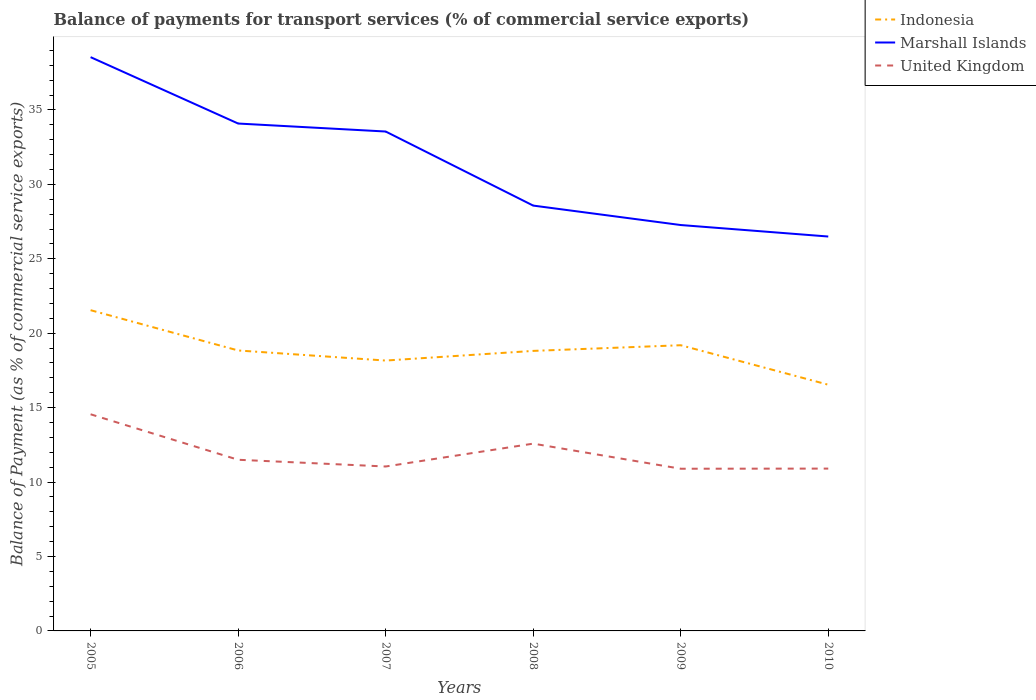How many different coloured lines are there?
Give a very brief answer. 3. Does the line corresponding to United Kingdom intersect with the line corresponding to Marshall Islands?
Give a very brief answer. No. Across all years, what is the maximum balance of payments for transport services in Indonesia?
Ensure brevity in your answer.  16.54. In which year was the balance of payments for transport services in Indonesia maximum?
Keep it short and to the point. 2010. What is the total balance of payments for transport services in United Kingdom in the graph?
Make the answer very short. 3.06. What is the difference between the highest and the second highest balance of payments for transport services in Indonesia?
Keep it short and to the point. 5.01. What is the difference between the highest and the lowest balance of payments for transport services in Marshall Islands?
Offer a terse response. 3. How many lines are there?
Offer a terse response. 3. How many years are there in the graph?
Your response must be concise. 6. Does the graph contain any zero values?
Ensure brevity in your answer.  No. Does the graph contain grids?
Provide a short and direct response. No. Where does the legend appear in the graph?
Make the answer very short. Top right. What is the title of the graph?
Give a very brief answer. Balance of payments for transport services (% of commercial service exports). Does "Singapore" appear as one of the legend labels in the graph?
Make the answer very short. No. What is the label or title of the Y-axis?
Offer a terse response. Balance of Payment (as % of commercial service exports). What is the Balance of Payment (as % of commercial service exports) of Indonesia in 2005?
Give a very brief answer. 21.55. What is the Balance of Payment (as % of commercial service exports) of Marshall Islands in 2005?
Your answer should be compact. 38.55. What is the Balance of Payment (as % of commercial service exports) in United Kingdom in 2005?
Your answer should be compact. 14.55. What is the Balance of Payment (as % of commercial service exports) of Indonesia in 2006?
Give a very brief answer. 18.84. What is the Balance of Payment (as % of commercial service exports) in Marshall Islands in 2006?
Give a very brief answer. 34.09. What is the Balance of Payment (as % of commercial service exports) of United Kingdom in 2006?
Your response must be concise. 11.5. What is the Balance of Payment (as % of commercial service exports) of Indonesia in 2007?
Keep it short and to the point. 18.16. What is the Balance of Payment (as % of commercial service exports) in Marshall Islands in 2007?
Provide a short and direct response. 33.55. What is the Balance of Payment (as % of commercial service exports) of United Kingdom in 2007?
Your answer should be compact. 11.05. What is the Balance of Payment (as % of commercial service exports) of Indonesia in 2008?
Provide a short and direct response. 18.81. What is the Balance of Payment (as % of commercial service exports) of Marshall Islands in 2008?
Your response must be concise. 28.57. What is the Balance of Payment (as % of commercial service exports) in United Kingdom in 2008?
Give a very brief answer. 12.58. What is the Balance of Payment (as % of commercial service exports) in Indonesia in 2009?
Offer a terse response. 19.19. What is the Balance of Payment (as % of commercial service exports) of Marshall Islands in 2009?
Provide a short and direct response. 27.27. What is the Balance of Payment (as % of commercial service exports) in United Kingdom in 2009?
Keep it short and to the point. 10.9. What is the Balance of Payment (as % of commercial service exports) of Indonesia in 2010?
Your answer should be very brief. 16.54. What is the Balance of Payment (as % of commercial service exports) in Marshall Islands in 2010?
Make the answer very short. 26.5. What is the Balance of Payment (as % of commercial service exports) of United Kingdom in 2010?
Your answer should be very brief. 10.91. Across all years, what is the maximum Balance of Payment (as % of commercial service exports) of Indonesia?
Provide a succinct answer. 21.55. Across all years, what is the maximum Balance of Payment (as % of commercial service exports) of Marshall Islands?
Your answer should be compact. 38.55. Across all years, what is the maximum Balance of Payment (as % of commercial service exports) of United Kingdom?
Offer a terse response. 14.55. Across all years, what is the minimum Balance of Payment (as % of commercial service exports) in Indonesia?
Offer a terse response. 16.54. Across all years, what is the minimum Balance of Payment (as % of commercial service exports) of Marshall Islands?
Provide a succinct answer. 26.5. Across all years, what is the minimum Balance of Payment (as % of commercial service exports) in United Kingdom?
Keep it short and to the point. 10.9. What is the total Balance of Payment (as % of commercial service exports) of Indonesia in the graph?
Make the answer very short. 113.09. What is the total Balance of Payment (as % of commercial service exports) in Marshall Islands in the graph?
Offer a very short reply. 188.52. What is the total Balance of Payment (as % of commercial service exports) in United Kingdom in the graph?
Offer a very short reply. 71.48. What is the difference between the Balance of Payment (as % of commercial service exports) in Indonesia in 2005 and that in 2006?
Offer a terse response. 2.71. What is the difference between the Balance of Payment (as % of commercial service exports) of Marshall Islands in 2005 and that in 2006?
Your answer should be very brief. 4.46. What is the difference between the Balance of Payment (as % of commercial service exports) in United Kingdom in 2005 and that in 2006?
Your response must be concise. 3.06. What is the difference between the Balance of Payment (as % of commercial service exports) of Indonesia in 2005 and that in 2007?
Offer a terse response. 3.38. What is the difference between the Balance of Payment (as % of commercial service exports) in Marshall Islands in 2005 and that in 2007?
Give a very brief answer. 5. What is the difference between the Balance of Payment (as % of commercial service exports) in United Kingdom in 2005 and that in 2007?
Offer a terse response. 3.51. What is the difference between the Balance of Payment (as % of commercial service exports) of Indonesia in 2005 and that in 2008?
Ensure brevity in your answer.  2.73. What is the difference between the Balance of Payment (as % of commercial service exports) in Marshall Islands in 2005 and that in 2008?
Ensure brevity in your answer.  9.97. What is the difference between the Balance of Payment (as % of commercial service exports) in United Kingdom in 2005 and that in 2008?
Your response must be concise. 1.97. What is the difference between the Balance of Payment (as % of commercial service exports) in Indonesia in 2005 and that in 2009?
Make the answer very short. 2.35. What is the difference between the Balance of Payment (as % of commercial service exports) of Marshall Islands in 2005 and that in 2009?
Ensure brevity in your answer.  11.28. What is the difference between the Balance of Payment (as % of commercial service exports) in United Kingdom in 2005 and that in 2009?
Provide a succinct answer. 3.66. What is the difference between the Balance of Payment (as % of commercial service exports) in Indonesia in 2005 and that in 2010?
Provide a short and direct response. 5.01. What is the difference between the Balance of Payment (as % of commercial service exports) of Marshall Islands in 2005 and that in 2010?
Make the answer very short. 12.05. What is the difference between the Balance of Payment (as % of commercial service exports) in United Kingdom in 2005 and that in 2010?
Ensure brevity in your answer.  3.65. What is the difference between the Balance of Payment (as % of commercial service exports) of Indonesia in 2006 and that in 2007?
Your response must be concise. 0.68. What is the difference between the Balance of Payment (as % of commercial service exports) in Marshall Islands in 2006 and that in 2007?
Ensure brevity in your answer.  0.54. What is the difference between the Balance of Payment (as % of commercial service exports) of United Kingdom in 2006 and that in 2007?
Give a very brief answer. 0.45. What is the difference between the Balance of Payment (as % of commercial service exports) of Indonesia in 2006 and that in 2008?
Give a very brief answer. 0.03. What is the difference between the Balance of Payment (as % of commercial service exports) of Marshall Islands in 2006 and that in 2008?
Your answer should be very brief. 5.51. What is the difference between the Balance of Payment (as % of commercial service exports) in United Kingdom in 2006 and that in 2008?
Provide a short and direct response. -1.08. What is the difference between the Balance of Payment (as % of commercial service exports) in Indonesia in 2006 and that in 2009?
Your response must be concise. -0.35. What is the difference between the Balance of Payment (as % of commercial service exports) in Marshall Islands in 2006 and that in 2009?
Keep it short and to the point. 6.82. What is the difference between the Balance of Payment (as % of commercial service exports) in United Kingdom in 2006 and that in 2009?
Make the answer very short. 0.6. What is the difference between the Balance of Payment (as % of commercial service exports) in Indonesia in 2006 and that in 2010?
Your answer should be compact. 2.3. What is the difference between the Balance of Payment (as % of commercial service exports) in Marshall Islands in 2006 and that in 2010?
Offer a very short reply. 7.59. What is the difference between the Balance of Payment (as % of commercial service exports) of United Kingdom in 2006 and that in 2010?
Your answer should be very brief. 0.59. What is the difference between the Balance of Payment (as % of commercial service exports) of Indonesia in 2007 and that in 2008?
Ensure brevity in your answer.  -0.65. What is the difference between the Balance of Payment (as % of commercial service exports) in Marshall Islands in 2007 and that in 2008?
Give a very brief answer. 4.98. What is the difference between the Balance of Payment (as % of commercial service exports) in United Kingdom in 2007 and that in 2008?
Give a very brief answer. -1.54. What is the difference between the Balance of Payment (as % of commercial service exports) in Indonesia in 2007 and that in 2009?
Offer a very short reply. -1.03. What is the difference between the Balance of Payment (as % of commercial service exports) of Marshall Islands in 2007 and that in 2009?
Give a very brief answer. 6.28. What is the difference between the Balance of Payment (as % of commercial service exports) of United Kingdom in 2007 and that in 2009?
Offer a very short reply. 0.15. What is the difference between the Balance of Payment (as % of commercial service exports) of Indonesia in 2007 and that in 2010?
Make the answer very short. 1.62. What is the difference between the Balance of Payment (as % of commercial service exports) in Marshall Islands in 2007 and that in 2010?
Offer a terse response. 7.05. What is the difference between the Balance of Payment (as % of commercial service exports) in United Kingdom in 2007 and that in 2010?
Your answer should be very brief. 0.14. What is the difference between the Balance of Payment (as % of commercial service exports) in Indonesia in 2008 and that in 2009?
Ensure brevity in your answer.  -0.38. What is the difference between the Balance of Payment (as % of commercial service exports) in Marshall Islands in 2008 and that in 2009?
Your answer should be very brief. 1.31. What is the difference between the Balance of Payment (as % of commercial service exports) of United Kingdom in 2008 and that in 2009?
Keep it short and to the point. 1.69. What is the difference between the Balance of Payment (as % of commercial service exports) of Indonesia in 2008 and that in 2010?
Your answer should be very brief. 2.27. What is the difference between the Balance of Payment (as % of commercial service exports) in Marshall Islands in 2008 and that in 2010?
Offer a terse response. 2.08. What is the difference between the Balance of Payment (as % of commercial service exports) of United Kingdom in 2008 and that in 2010?
Your answer should be very brief. 1.68. What is the difference between the Balance of Payment (as % of commercial service exports) of Indonesia in 2009 and that in 2010?
Keep it short and to the point. 2.65. What is the difference between the Balance of Payment (as % of commercial service exports) in Marshall Islands in 2009 and that in 2010?
Make the answer very short. 0.77. What is the difference between the Balance of Payment (as % of commercial service exports) in United Kingdom in 2009 and that in 2010?
Ensure brevity in your answer.  -0.01. What is the difference between the Balance of Payment (as % of commercial service exports) in Indonesia in 2005 and the Balance of Payment (as % of commercial service exports) in Marshall Islands in 2006?
Give a very brief answer. -12.54. What is the difference between the Balance of Payment (as % of commercial service exports) in Indonesia in 2005 and the Balance of Payment (as % of commercial service exports) in United Kingdom in 2006?
Provide a succinct answer. 10.05. What is the difference between the Balance of Payment (as % of commercial service exports) in Marshall Islands in 2005 and the Balance of Payment (as % of commercial service exports) in United Kingdom in 2006?
Ensure brevity in your answer.  27.05. What is the difference between the Balance of Payment (as % of commercial service exports) in Indonesia in 2005 and the Balance of Payment (as % of commercial service exports) in Marshall Islands in 2007?
Your response must be concise. -12. What is the difference between the Balance of Payment (as % of commercial service exports) of Indonesia in 2005 and the Balance of Payment (as % of commercial service exports) of United Kingdom in 2007?
Ensure brevity in your answer.  10.5. What is the difference between the Balance of Payment (as % of commercial service exports) in Marshall Islands in 2005 and the Balance of Payment (as % of commercial service exports) in United Kingdom in 2007?
Offer a terse response. 27.5. What is the difference between the Balance of Payment (as % of commercial service exports) in Indonesia in 2005 and the Balance of Payment (as % of commercial service exports) in Marshall Islands in 2008?
Your answer should be very brief. -7.03. What is the difference between the Balance of Payment (as % of commercial service exports) of Indonesia in 2005 and the Balance of Payment (as % of commercial service exports) of United Kingdom in 2008?
Make the answer very short. 8.96. What is the difference between the Balance of Payment (as % of commercial service exports) of Marshall Islands in 2005 and the Balance of Payment (as % of commercial service exports) of United Kingdom in 2008?
Ensure brevity in your answer.  25.96. What is the difference between the Balance of Payment (as % of commercial service exports) in Indonesia in 2005 and the Balance of Payment (as % of commercial service exports) in Marshall Islands in 2009?
Your answer should be very brief. -5.72. What is the difference between the Balance of Payment (as % of commercial service exports) of Indonesia in 2005 and the Balance of Payment (as % of commercial service exports) of United Kingdom in 2009?
Give a very brief answer. 10.65. What is the difference between the Balance of Payment (as % of commercial service exports) of Marshall Islands in 2005 and the Balance of Payment (as % of commercial service exports) of United Kingdom in 2009?
Your answer should be very brief. 27.65. What is the difference between the Balance of Payment (as % of commercial service exports) in Indonesia in 2005 and the Balance of Payment (as % of commercial service exports) in Marshall Islands in 2010?
Offer a very short reply. -4.95. What is the difference between the Balance of Payment (as % of commercial service exports) in Indonesia in 2005 and the Balance of Payment (as % of commercial service exports) in United Kingdom in 2010?
Make the answer very short. 10.64. What is the difference between the Balance of Payment (as % of commercial service exports) in Marshall Islands in 2005 and the Balance of Payment (as % of commercial service exports) in United Kingdom in 2010?
Make the answer very short. 27.64. What is the difference between the Balance of Payment (as % of commercial service exports) of Indonesia in 2006 and the Balance of Payment (as % of commercial service exports) of Marshall Islands in 2007?
Provide a short and direct response. -14.71. What is the difference between the Balance of Payment (as % of commercial service exports) in Indonesia in 2006 and the Balance of Payment (as % of commercial service exports) in United Kingdom in 2007?
Your answer should be compact. 7.8. What is the difference between the Balance of Payment (as % of commercial service exports) in Marshall Islands in 2006 and the Balance of Payment (as % of commercial service exports) in United Kingdom in 2007?
Ensure brevity in your answer.  23.04. What is the difference between the Balance of Payment (as % of commercial service exports) of Indonesia in 2006 and the Balance of Payment (as % of commercial service exports) of Marshall Islands in 2008?
Keep it short and to the point. -9.73. What is the difference between the Balance of Payment (as % of commercial service exports) of Indonesia in 2006 and the Balance of Payment (as % of commercial service exports) of United Kingdom in 2008?
Offer a terse response. 6.26. What is the difference between the Balance of Payment (as % of commercial service exports) in Marshall Islands in 2006 and the Balance of Payment (as % of commercial service exports) in United Kingdom in 2008?
Your response must be concise. 21.5. What is the difference between the Balance of Payment (as % of commercial service exports) of Indonesia in 2006 and the Balance of Payment (as % of commercial service exports) of Marshall Islands in 2009?
Keep it short and to the point. -8.43. What is the difference between the Balance of Payment (as % of commercial service exports) in Indonesia in 2006 and the Balance of Payment (as % of commercial service exports) in United Kingdom in 2009?
Offer a terse response. 7.95. What is the difference between the Balance of Payment (as % of commercial service exports) in Marshall Islands in 2006 and the Balance of Payment (as % of commercial service exports) in United Kingdom in 2009?
Your response must be concise. 23.19. What is the difference between the Balance of Payment (as % of commercial service exports) in Indonesia in 2006 and the Balance of Payment (as % of commercial service exports) in Marshall Islands in 2010?
Offer a terse response. -7.65. What is the difference between the Balance of Payment (as % of commercial service exports) in Indonesia in 2006 and the Balance of Payment (as % of commercial service exports) in United Kingdom in 2010?
Ensure brevity in your answer.  7.94. What is the difference between the Balance of Payment (as % of commercial service exports) of Marshall Islands in 2006 and the Balance of Payment (as % of commercial service exports) of United Kingdom in 2010?
Give a very brief answer. 23.18. What is the difference between the Balance of Payment (as % of commercial service exports) in Indonesia in 2007 and the Balance of Payment (as % of commercial service exports) in Marshall Islands in 2008?
Offer a very short reply. -10.41. What is the difference between the Balance of Payment (as % of commercial service exports) of Indonesia in 2007 and the Balance of Payment (as % of commercial service exports) of United Kingdom in 2008?
Provide a short and direct response. 5.58. What is the difference between the Balance of Payment (as % of commercial service exports) of Marshall Islands in 2007 and the Balance of Payment (as % of commercial service exports) of United Kingdom in 2008?
Give a very brief answer. 20.97. What is the difference between the Balance of Payment (as % of commercial service exports) in Indonesia in 2007 and the Balance of Payment (as % of commercial service exports) in Marshall Islands in 2009?
Your response must be concise. -9.1. What is the difference between the Balance of Payment (as % of commercial service exports) of Indonesia in 2007 and the Balance of Payment (as % of commercial service exports) of United Kingdom in 2009?
Your answer should be compact. 7.27. What is the difference between the Balance of Payment (as % of commercial service exports) of Marshall Islands in 2007 and the Balance of Payment (as % of commercial service exports) of United Kingdom in 2009?
Your answer should be compact. 22.65. What is the difference between the Balance of Payment (as % of commercial service exports) in Indonesia in 2007 and the Balance of Payment (as % of commercial service exports) in Marshall Islands in 2010?
Offer a terse response. -8.33. What is the difference between the Balance of Payment (as % of commercial service exports) in Indonesia in 2007 and the Balance of Payment (as % of commercial service exports) in United Kingdom in 2010?
Provide a succinct answer. 7.26. What is the difference between the Balance of Payment (as % of commercial service exports) in Marshall Islands in 2007 and the Balance of Payment (as % of commercial service exports) in United Kingdom in 2010?
Provide a short and direct response. 22.64. What is the difference between the Balance of Payment (as % of commercial service exports) of Indonesia in 2008 and the Balance of Payment (as % of commercial service exports) of Marshall Islands in 2009?
Keep it short and to the point. -8.46. What is the difference between the Balance of Payment (as % of commercial service exports) of Indonesia in 2008 and the Balance of Payment (as % of commercial service exports) of United Kingdom in 2009?
Your response must be concise. 7.92. What is the difference between the Balance of Payment (as % of commercial service exports) in Marshall Islands in 2008 and the Balance of Payment (as % of commercial service exports) in United Kingdom in 2009?
Your answer should be very brief. 17.68. What is the difference between the Balance of Payment (as % of commercial service exports) in Indonesia in 2008 and the Balance of Payment (as % of commercial service exports) in Marshall Islands in 2010?
Make the answer very short. -7.68. What is the difference between the Balance of Payment (as % of commercial service exports) in Indonesia in 2008 and the Balance of Payment (as % of commercial service exports) in United Kingdom in 2010?
Your answer should be very brief. 7.91. What is the difference between the Balance of Payment (as % of commercial service exports) of Marshall Islands in 2008 and the Balance of Payment (as % of commercial service exports) of United Kingdom in 2010?
Provide a succinct answer. 17.67. What is the difference between the Balance of Payment (as % of commercial service exports) of Indonesia in 2009 and the Balance of Payment (as % of commercial service exports) of Marshall Islands in 2010?
Keep it short and to the point. -7.3. What is the difference between the Balance of Payment (as % of commercial service exports) of Indonesia in 2009 and the Balance of Payment (as % of commercial service exports) of United Kingdom in 2010?
Offer a terse response. 8.29. What is the difference between the Balance of Payment (as % of commercial service exports) of Marshall Islands in 2009 and the Balance of Payment (as % of commercial service exports) of United Kingdom in 2010?
Offer a very short reply. 16.36. What is the average Balance of Payment (as % of commercial service exports) in Indonesia per year?
Give a very brief answer. 18.85. What is the average Balance of Payment (as % of commercial service exports) in Marshall Islands per year?
Your answer should be very brief. 31.42. What is the average Balance of Payment (as % of commercial service exports) in United Kingdom per year?
Give a very brief answer. 11.91. In the year 2005, what is the difference between the Balance of Payment (as % of commercial service exports) of Indonesia and Balance of Payment (as % of commercial service exports) of Marshall Islands?
Your answer should be very brief. -17. In the year 2005, what is the difference between the Balance of Payment (as % of commercial service exports) in Indonesia and Balance of Payment (as % of commercial service exports) in United Kingdom?
Keep it short and to the point. 6.99. In the year 2005, what is the difference between the Balance of Payment (as % of commercial service exports) of Marshall Islands and Balance of Payment (as % of commercial service exports) of United Kingdom?
Ensure brevity in your answer.  23.99. In the year 2006, what is the difference between the Balance of Payment (as % of commercial service exports) of Indonesia and Balance of Payment (as % of commercial service exports) of Marshall Islands?
Provide a short and direct response. -15.25. In the year 2006, what is the difference between the Balance of Payment (as % of commercial service exports) of Indonesia and Balance of Payment (as % of commercial service exports) of United Kingdom?
Make the answer very short. 7.34. In the year 2006, what is the difference between the Balance of Payment (as % of commercial service exports) of Marshall Islands and Balance of Payment (as % of commercial service exports) of United Kingdom?
Offer a very short reply. 22.59. In the year 2007, what is the difference between the Balance of Payment (as % of commercial service exports) in Indonesia and Balance of Payment (as % of commercial service exports) in Marshall Islands?
Your response must be concise. -15.39. In the year 2007, what is the difference between the Balance of Payment (as % of commercial service exports) in Indonesia and Balance of Payment (as % of commercial service exports) in United Kingdom?
Offer a terse response. 7.12. In the year 2007, what is the difference between the Balance of Payment (as % of commercial service exports) in Marshall Islands and Balance of Payment (as % of commercial service exports) in United Kingdom?
Offer a terse response. 22.5. In the year 2008, what is the difference between the Balance of Payment (as % of commercial service exports) of Indonesia and Balance of Payment (as % of commercial service exports) of Marshall Islands?
Offer a very short reply. -9.76. In the year 2008, what is the difference between the Balance of Payment (as % of commercial service exports) in Indonesia and Balance of Payment (as % of commercial service exports) in United Kingdom?
Offer a very short reply. 6.23. In the year 2008, what is the difference between the Balance of Payment (as % of commercial service exports) in Marshall Islands and Balance of Payment (as % of commercial service exports) in United Kingdom?
Give a very brief answer. 15.99. In the year 2009, what is the difference between the Balance of Payment (as % of commercial service exports) of Indonesia and Balance of Payment (as % of commercial service exports) of Marshall Islands?
Give a very brief answer. -8.07. In the year 2009, what is the difference between the Balance of Payment (as % of commercial service exports) of Indonesia and Balance of Payment (as % of commercial service exports) of United Kingdom?
Offer a terse response. 8.3. In the year 2009, what is the difference between the Balance of Payment (as % of commercial service exports) of Marshall Islands and Balance of Payment (as % of commercial service exports) of United Kingdom?
Keep it short and to the point. 16.37. In the year 2010, what is the difference between the Balance of Payment (as % of commercial service exports) of Indonesia and Balance of Payment (as % of commercial service exports) of Marshall Islands?
Your answer should be very brief. -9.96. In the year 2010, what is the difference between the Balance of Payment (as % of commercial service exports) of Indonesia and Balance of Payment (as % of commercial service exports) of United Kingdom?
Offer a terse response. 5.63. In the year 2010, what is the difference between the Balance of Payment (as % of commercial service exports) of Marshall Islands and Balance of Payment (as % of commercial service exports) of United Kingdom?
Keep it short and to the point. 15.59. What is the ratio of the Balance of Payment (as % of commercial service exports) in Indonesia in 2005 to that in 2006?
Keep it short and to the point. 1.14. What is the ratio of the Balance of Payment (as % of commercial service exports) in Marshall Islands in 2005 to that in 2006?
Your response must be concise. 1.13. What is the ratio of the Balance of Payment (as % of commercial service exports) in United Kingdom in 2005 to that in 2006?
Your answer should be very brief. 1.27. What is the ratio of the Balance of Payment (as % of commercial service exports) of Indonesia in 2005 to that in 2007?
Make the answer very short. 1.19. What is the ratio of the Balance of Payment (as % of commercial service exports) of Marshall Islands in 2005 to that in 2007?
Offer a very short reply. 1.15. What is the ratio of the Balance of Payment (as % of commercial service exports) in United Kingdom in 2005 to that in 2007?
Your answer should be very brief. 1.32. What is the ratio of the Balance of Payment (as % of commercial service exports) of Indonesia in 2005 to that in 2008?
Provide a short and direct response. 1.15. What is the ratio of the Balance of Payment (as % of commercial service exports) in Marshall Islands in 2005 to that in 2008?
Keep it short and to the point. 1.35. What is the ratio of the Balance of Payment (as % of commercial service exports) in United Kingdom in 2005 to that in 2008?
Give a very brief answer. 1.16. What is the ratio of the Balance of Payment (as % of commercial service exports) in Indonesia in 2005 to that in 2009?
Provide a succinct answer. 1.12. What is the ratio of the Balance of Payment (as % of commercial service exports) of Marshall Islands in 2005 to that in 2009?
Your answer should be compact. 1.41. What is the ratio of the Balance of Payment (as % of commercial service exports) of United Kingdom in 2005 to that in 2009?
Provide a short and direct response. 1.34. What is the ratio of the Balance of Payment (as % of commercial service exports) of Indonesia in 2005 to that in 2010?
Your answer should be very brief. 1.3. What is the ratio of the Balance of Payment (as % of commercial service exports) of Marshall Islands in 2005 to that in 2010?
Offer a terse response. 1.45. What is the ratio of the Balance of Payment (as % of commercial service exports) in United Kingdom in 2005 to that in 2010?
Provide a succinct answer. 1.33. What is the ratio of the Balance of Payment (as % of commercial service exports) of Indonesia in 2006 to that in 2007?
Ensure brevity in your answer.  1.04. What is the ratio of the Balance of Payment (as % of commercial service exports) in Marshall Islands in 2006 to that in 2007?
Give a very brief answer. 1.02. What is the ratio of the Balance of Payment (as % of commercial service exports) of United Kingdom in 2006 to that in 2007?
Offer a terse response. 1.04. What is the ratio of the Balance of Payment (as % of commercial service exports) of Marshall Islands in 2006 to that in 2008?
Offer a very short reply. 1.19. What is the ratio of the Balance of Payment (as % of commercial service exports) of United Kingdom in 2006 to that in 2008?
Keep it short and to the point. 0.91. What is the ratio of the Balance of Payment (as % of commercial service exports) in Indonesia in 2006 to that in 2009?
Ensure brevity in your answer.  0.98. What is the ratio of the Balance of Payment (as % of commercial service exports) in Marshall Islands in 2006 to that in 2009?
Provide a short and direct response. 1.25. What is the ratio of the Balance of Payment (as % of commercial service exports) of United Kingdom in 2006 to that in 2009?
Ensure brevity in your answer.  1.06. What is the ratio of the Balance of Payment (as % of commercial service exports) of Indonesia in 2006 to that in 2010?
Your response must be concise. 1.14. What is the ratio of the Balance of Payment (as % of commercial service exports) in Marshall Islands in 2006 to that in 2010?
Your answer should be very brief. 1.29. What is the ratio of the Balance of Payment (as % of commercial service exports) in United Kingdom in 2006 to that in 2010?
Make the answer very short. 1.05. What is the ratio of the Balance of Payment (as % of commercial service exports) in Indonesia in 2007 to that in 2008?
Offer a terse response. 0.97. What is the ratio of the Balance of Payment (as % of commercial service exports) of Marshall Islands in 2007 to that in 2008?
Offer a very short reply. 1.17. What is the ratio of the Balance of Payment (as % of commercial service exports) in United Kingdom in 2007 to that in 2008?
Keep it short and to the point. 0.88. What is the ratio of the Balance of Payment (as % of commercial service exports) in Indonesia in 2007 to that in 2009?
Your answer should be very brief. 0.95. What is the ratio of the Balance of Payment (as % of commercial service exports) in Marshall Islands in 2007 to that in 2009?
Ensure brevity in your answer.  1.23. What is the ratio of the Balance of Payment (as % of commercial service exports) in United Kingdom in 2007 to that in 2009?
Your answer should be compact. 1.01. What is the ratio of the Balance of Payment (as % of commercial service exports) of Indonesia in 2007 to that in 2010?
Offer a terse response. 1.1. What is the ratio of the Balance of Payment (as % of commercial service exports) in Marshall Islands in 2007 to that in 2010?
Your answer should be compact. 1.27. What is the ratio of the Balance of Payment (as % of commercial service exports) of United Kingdom in 2007 to that in 2010?
Provide a succinct answer. 1.01. What is the ratio of the Balance of Payment (as % of commercial service exports) of Indonesia in 2008 to that in 2009?
Provide a succinct answer. 0.98. What is the ratio of the Balance of Payment (as % of commercial service exports) of Marshall Islands in 2008 to that in 2009?
Offer a terse response. 1.05. What is the ratio of the Balance of Payment (as % of commercial service exports) in United Kingdom in 2008 to that in 2009?
Keep it short and to the point. 1.15. What is the ratio of the Balance of Payment (as % of commercial service exports) in Indonesia in 2008 to that in 2010?
Provide a succinct answer. 1.14. What is the ratio of the Balance of Payment (as % of commercial service exports) of Marshall Islands in 2008 to that in 2010?
Your response must be concise. 1.08. What is the ratio of the Balance of Payment (as % of commercial service exports) in United Kingdom in 2008 to that in 2010?
Your answer should be compact. 1.15. What is the ratio of the Balance of Payment (as % of commercial service exports) of Indonesia in 2009 to that in 2010?
Give a very brief answer. 1.16. What is the ratio of the Balance of Payment (as % of commercial service exports) in Marshall Islands in 2009 to that in 2010?
Keep it short and to the point. 1.03. What is the difference between the highest and the second highest Balance of Payment (as % of commercial service exports) in Indonesia?
Make the answer very short. 2.35. What is the difference between the highest and the second highest Balance of Payment (as % of commercial service exports) in Marshall Islands?
Your answer should be compact. 4.46. What is the difference between the highest and the second highest Balance of Payment (as % of commercial service exports) in United Kingdom?
Offer a very short reply. 1.97. What is the difference between the highest and the lowest Balance of Payment (as % of commercial service exports) in Indonesia?
Your answer should be very brief. 5.01. What is the difference between the highest and the lowest Balance of Payment (as % of commercial service exports) of Marshall Islands?
Ensure brevity in your answer.  12.05. What is the difference between the highest and the lowest Balance of Payment (as % of commercial service exports) in United Kingdom?
Make the answer very short. 3.66. 